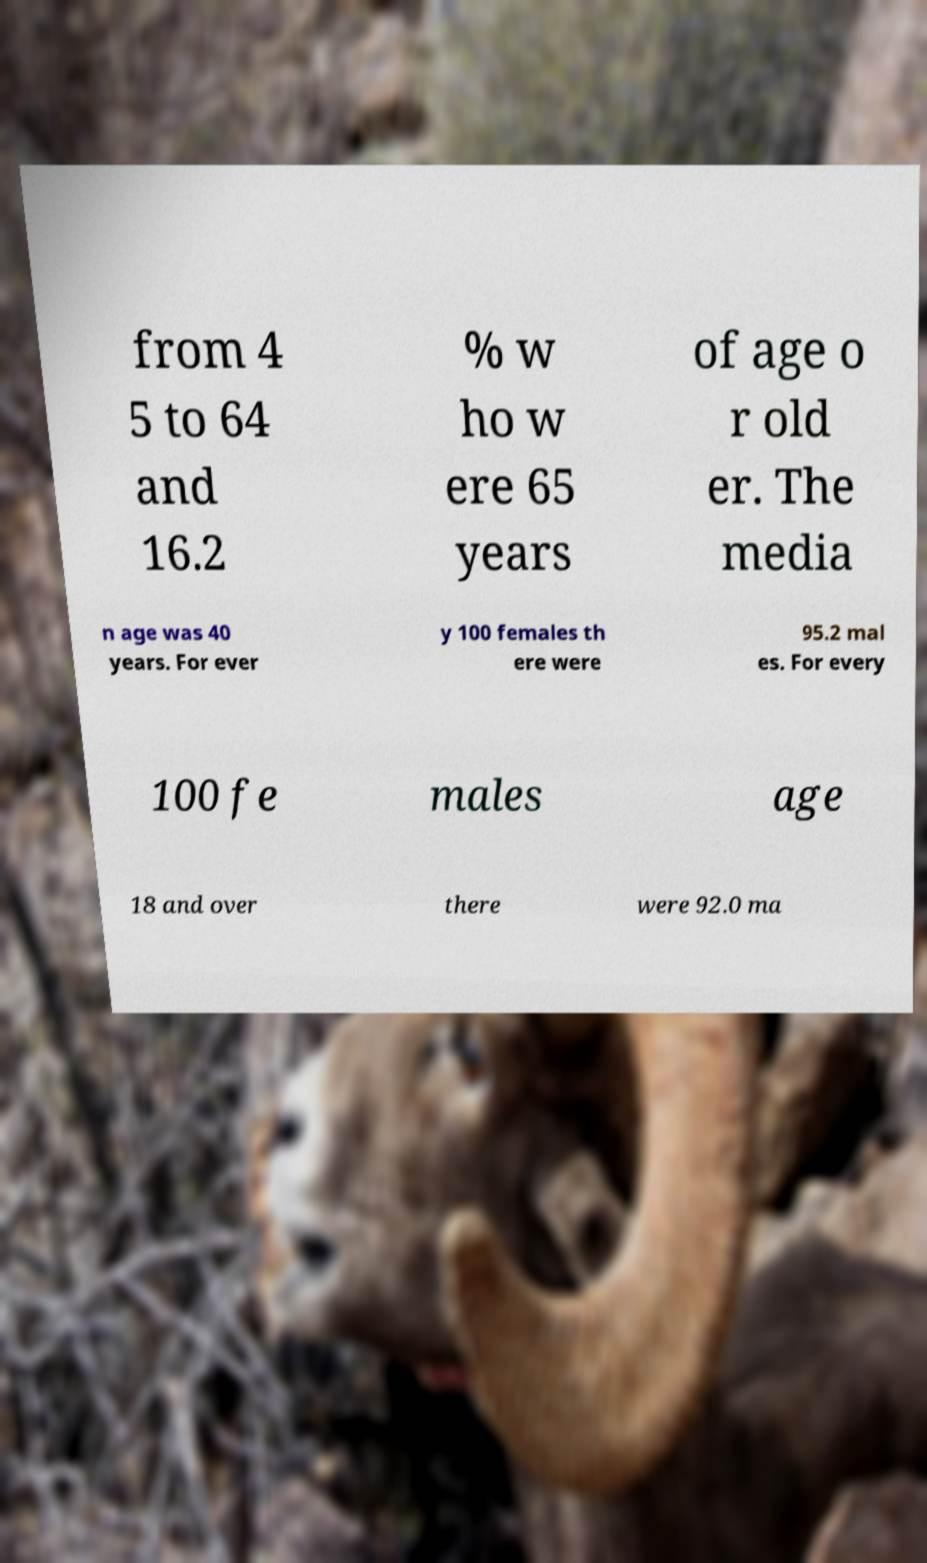Could you extract and type out the text from this image? from 4 5 to 64 and 16.2 % w ho w ere 65 years of age o r old er. The media n age was 40 years. For ever y 100 females th ere were 95.2 mal es. For every 100 fe males age 18 and over there were 92.0 ma 